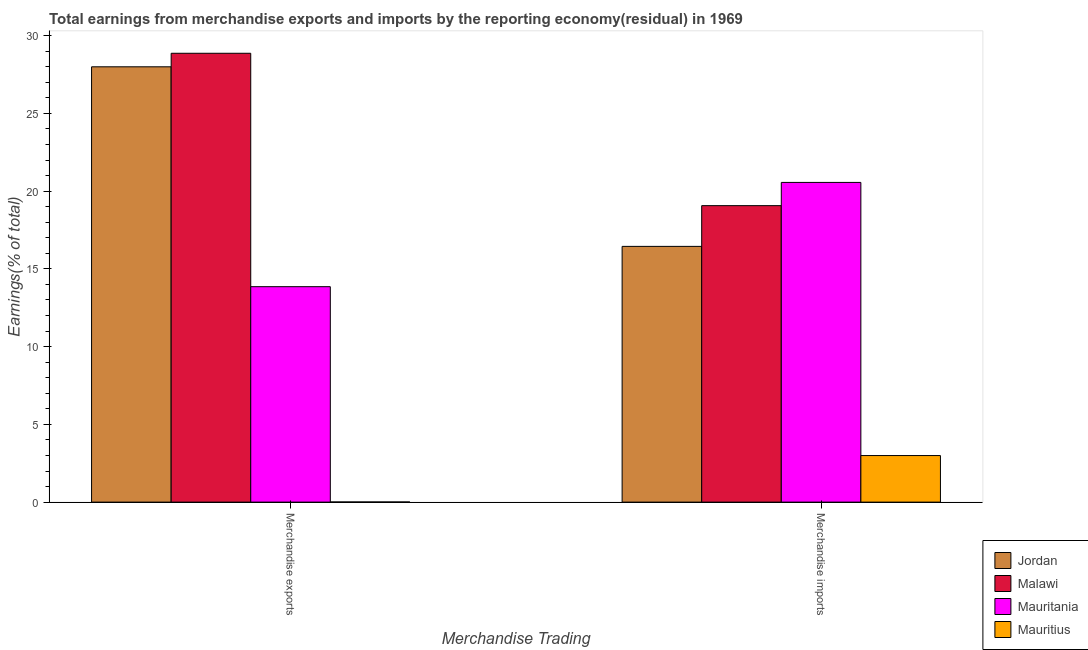How many different coloured bars are there?
Your answer should be very brief. 4. Are the number of bars on each tick of the X-axis equal?
Provide a succinct answer. Yes. How many bars are there on the 2nd tick from the right?
Ensure brevity in your answer.  4. What is the label of the 2nd group of bars from the left?
Make the answer very short. Merchandise imports. What is the earnings from merchandise exports in Malawi?
Your answer should be very brief. 28.87. Across all countries, what is the maximum earnings from merchandise imports?
Keep it short and to the point. 20.56. Across all countries, what is the minimum earnings from merchandise imports?
Your response must be concise. 3. In which country was the earnings from merchandise exports maximum?
Offer a very short reply. Malawi. In which country was the earnings from merchandise imports minimum?
Your answer should be very brief. Mauritius. What is the total earnings from merchandise imports in the graph?
Provide a succinct answer. 59.07. What is the difference between the earnings from merchandise exports in Mauritius and that in Malawi?
Your response must be concise. -28.86. What is the difference between the earnings from merchandise exports in Mauritius and the earnings from merchandise imports in Mauritania?
Provide a short and direct response. -20.55. What is the average earnings from merchandise exports per country?
Your response must be concise. 17.68. What is the difference between the earnings from merchandise exports and earnings from merchandise imports in Mauritius?
Offer a terse response. -2.99. In how many countries, is the earnings from merchandise exports greater than 6 %?
Provide a succinct answer. 3. What is the ratio of the earnings from merchandise imports in Mauritania to that in Malawi?
Offer a terse response. 1.08. In how many countries, is the earnings from merchandise imports greater than the average earnings from merchandise imports taken over all countries?
Ensure brevity in your answer.  3. What does the 3rd bar from the left in Merchandise exports represents?
Your response must be concise. Mauritania. What does the 3rd bar from the right in Merchandise exports represents?
Keep it short and to the point. Malawi. How many bars are there?
Give a very brief answer. 8. Are all the bars in the graph horizontal?
Your answer should be compact. No. What is the difference between two consecutive major ticks on the Y-axis?
Offer a terse response. 5. Are the values on the major ticks of Y-axis written in scientific E-notation?
Your answer should be very brief. No. Does the graph contain any zero values?
Give a very brief answer. No. Where does the legend appear in the graph?
Your answer should be very brief. Bottom right. What is the title of the graph?
Keep it short and to the point. Total earnings from merchandise exports and imports by the reporting economy(residual) in 1969. What is the label or title of the X-axis?
Your answer should be very brief. Merchandise Trading. What is the label or title of the Y-axis?
Your answer should be compact. Earnings(% of total). What is the Earnings(% of total) of Jordan in Merchandise exports?
Your answer should be very brief. 27.99. What is the Earnings(% of total) in Malawi in Merchandise exports?
Make the answer very short. 28.87. What is the Earnings(% of total) in Mauritania in Merchandise exports?
Offer a terse response. 13.86. What is the Earnings(% of total) in Mauritius in Merchandise exports?
Make the answer very short. 0.01. What is the Earnings(% of total) of Jordan in Merchandise imports?
Provide a short and direct response. 16.45. What is the Earnings(% of total) of Malawi in Merchandise imports?
Offer a terse response. 19.07. What is the Earnings(% of total) of Mauritania in Merchandise imports?
Offer a very short reply. 20.56. What is the Earnings(% of total) in Mauritius in Merchandise imports?
Provide a succinct answer. 3. Across all Merchandise Trading, what is the maximum Earnings(% of total) in Jordan?
Your response must be concise. 27.99. Across all Merchandise Trading, what is the maximum Earnings(% of total) in Malawi?
Offer a very short reply. 28.87. Across all Merchandise Trading, what is the maximum Earnings(% of total) of Mauritania?
Provide a succinct answer. 20.56. Across all Merchandise Trading, what is the maximum Earnings(% of total) of Mauritius?
Your response must be concise. 3. Across all Merchandise Trading, what is the minimum Earnings(% of total) of Jordan?
Give a very brief answer. 16.45. Across all Merchandise Trading, what is the minimum Earnings(% of total) of Malawi?
Offer a terse response. 19.07. Across all Merchandise Trading, what is the minimum Earnings(% of total) in Mauritania?
Give a very brief answer. 13.86. Across all Merchandise Trading, what is the minimum Earnings(% of total) of Mauritius?
Your response must be concise. 0.01. What is the total Earnings(% of total) in Jordan in the graph?
Offer a very short reply. 44.44. What is the total Earnings(% of total) in Malawi in the graph?
Your response must be concise. 47.93. What is the total Earnings(% of total) in Mauritania in the graph?
Your answer should be compact. 34.42. What is the total Earnings(% of total) in Mauritius in the graph?
Provide a short and direct response. 3. What is the difference between the Earnings(% of total) in Jordan in Merchandise exports and that in Merchandise imports?
Your answer should be very brief. 11.55. What is the difference between the Earnings(% of total) of Malawi in Merchandise exports and that in Merchandise imports?
Make the answer very short. 9.8. What is the difference between the Earnings(% of total) of Mauritania in Merchandise exports and that in Merchandise imports?
Your answer should be compact. -6.71. What is the difference between the Earnings(% of total) of Mauritius in Merchandise exports and that in Merchandise imports?
Provide a short and direct response. -2.99. What is the difference between the Earnings(% of total) in Jordan in Merchandise exports and the Earnings(% of total) in Malawi in Merchandise imports?
Offer a terse response. 8.93. What is the difference between the Earnings(% of total) of Jordan in Merchandise exports and the Earnings(% of total) of Mauritania in Merchandise imports?
Offer a terse response. 7.43. What is the difference between the Earnings(% of total) of Jordan in Merchandise exports and the Earnings(% of total) of Mauritius in Merchandise imports?
Your answer should be very brief. 25. What is the difference between the Earnings(% of total) in Malawi in Merchandise exports and the Earnings(% of total) in Mauritania in Merchandise imports?
Give a very brief answer. 8.3. What is the difference between the Earnings(% of total) of Malawi in Merchandise exports and the Earnings(% of total) of Mauritius in Merchandise imports?
Your answer should be compact. 25.87. What is the difference between the Earnings(% of total) of Mauritania in Merchandise exports and the Earnings(% of total) of Mauritius in Merchandise imports?
Offer a terse response. 10.86. What is the average Earnings(% of total) in Jordan per Merchandise Trading?
Offer a terse response. 22.22. What is the average Earnings(% of total) in Malawi per Merchandise Trading?
Give a very brief answer. 23.97. What is the average Earnings(% of total) of Mauritania per Merchandise Trading?
Your answer should be very brief. 17.21. What is the average Earnings(% of total) of Mauritius per Merchandise Trading?
Offer a very short reply. 1.5. What is the difference between the Earnings(% of total) of Jordan and Earnings(% of total) of Malawi in Merchandise exports?
Your response must be concise. -0.87. What is the difference between the Earnings(% of total) of Jordan and Earnings(% of total) of Mauritania in Merchandise exports?
Ensure brevity in your answer.  14.14. What is the difference between the Earnings(% of total) in Jordan and Earnings(% of total) in Mauritius in Merchandise exports?
Give a very brief answer. 27.98. What is the difference between the Earnings(% of total) in Malawi and Earnings(% of total) in Mauritania in Merchandise exports?
Offer a very short reply. 15.01. What is the difference between the Earnings(% of total) in Malawi and Earnings(% of total) in Mauritius in Merchandise exports?
Your response must be concise. 28.86. What is the difference between the Earnings(% of total) of Mauritania and Earnings(% of total) of Mauritius in Merchandise exports?
Your answer should be compact. 13.85. What is the difference between the Earnings(% of total) in Jordan and Earnings(% of total) in Malawi in Merchandise imports?
Make the answer very short. -2.62. What is the difference between the Earnings(% of total) in Jordan and Earnings(% of total) in Mauritania in Merchandise imports?
Make the answer very short. -4.11. What is the difference between the Earnings(% of total) of Jordan and Earnings(% of total) of Mauritius in Merchandise imports?
Ensure brevity in your answer.  13.45. What is the difference between the Earnings(% of total) in Malawi and Earnings(% of total) in Mauritania in Merchandise imports?
Provide a succinct answer. -1.5. What is the difference between the Earnings(% of total) of Malawi and Earnings(% of total) of Mauritius in Merchandise imports?
Provide a succinct answer. 16.07. What is the difference between the Earnings(% of total) of Mauritania and Earnings(% of total) of Mauritius in Merchandise imports?
Offer a very short reply. 17.57. What is the ratio of the Earnings(% of total) in Jordan in Merchandise exports to that in Merchandise imports?
Give a very brief answer. 1.7. What is the ratio of the Earnings(% of total) in Malawi in Merchandise exports to that in Merchandise imports?
Make the answer very short. 1.51. What is the ratio of the Earnings(% of total) of Mauritania in Merchandise exports to that in Merchandise imports?
Offer a very short reply. 0.67. What is the ratio of the Earnings(% of total) in Mauritius in Merchandise exports to that in Merchandise imports?
Give a very brief answer. 0. What is the difference between the highest and the second highest Earnings(% of total) of Jordan?
Your answer should be compact. 11.55. What is the difference between the highest and the second highest Earnings(% of total) of Malawi?
Ensure brevity in your answer.  9.8. What is the difference between the highest and the second highest Earnings(% of total) in Mauritania?
Make the answer very short. 6.71. What is the difference between the highest and the second highest Earnings(% of total) of Mauritius?
Your response must be concise. 2.99. What is the difference between the highest and the lowest Earnings(% of total) in Jordan?
Provide a short and direct response. 11.55. What is the difference between the highest and the lowest Earnings(% of total) in Malawi?
Your answer should be compact. 9.8. What is the difference between the highest and the lowest Earnings(% of total) of Mauritania?
Give a very brief answer. 6.71. What is the difference between the highest and the lowest Earnings(% of total) of Mauritius?
Your answer should be compact. 2.99. 